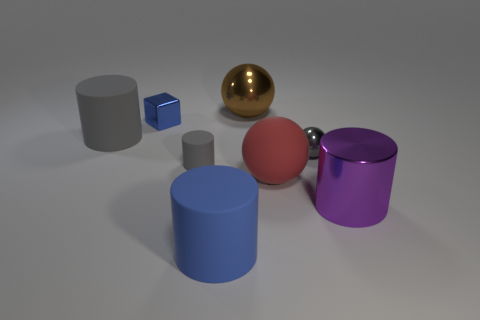There is a cylinder that is right of the big sphere that is in front of the small metallic cube; what is its size?
Offer a terse response. Large. What is the material of the small sphere that is the same color as the tiny rubber cylinder?
Offer a terse response. Metal. What size is the blue thing that is behind the large metallic thing in front of the tiny gray matte cylinder that is to the right of the small cube?
Your answer should be very brief. Small. Does the small object that is behind the large gray cylinder have the same color as the matte cylinder in front of the metal cylinder?
Offer a terse response. Yes. What number of gray objects are either tiny cylinders or tiny metallic spheres?
Your answer should be very brief. 2. What number of blue objects have the same size as the gray metal thing?
Your answer should be compact. 1. Does the cylinder that is behind the gray metallic object have the same material as the small gray cylinder?
Provide a short and direct response. Yes. There is a large cylinder in front of the big purple metal thing; are there any big purple shiny cylinders that are behind it?
Offer a terse response. Yes. There is another large object that is the same shape as the red object; what is it made of?
Ensure brevity in your answer.  Metal. Is the number of large cylinders that are on the right side of the tiny sphere greater than the number of small things to the right of the large red rubber thing?
Your answer should be compact. No. 